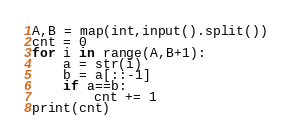<code> <loc_0><loc_0><loc_500><loc_500><_Python_>A,B = map(int,input().split())
cnt = 0
for i in range(A,B+1):
    a = str(i)
    b = a[::-1]
    if a==b:
        cnt += 1
print(cnt)</code> 